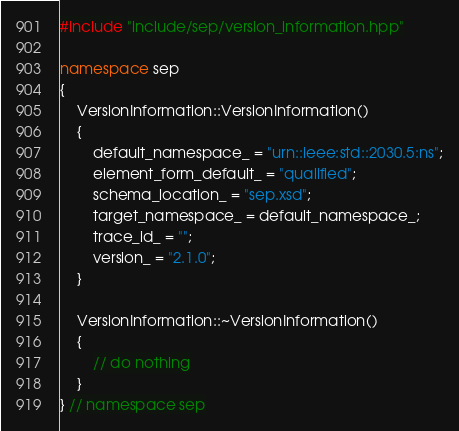<code> <loc_0><loc_0><loc_500><loc_500><_C++_>
#include "include/sep/version_information.hpp"

namespace sep
{
    VersionInformation::VersionInformation()
    {
        default_namespace_ = "urn::ieee:std::2030.5:ns";
        element_form_default_ = "qualified";
        schema_location_ = "sep.xsd";
        target_namespace_ = default_namespace_;
        trace_id_ = "";
        version_ = "2.1.0";
    }

    VersionInformation::~VersionInformation()
    {
        // do nothing
    }
} // namespace sep</code> 